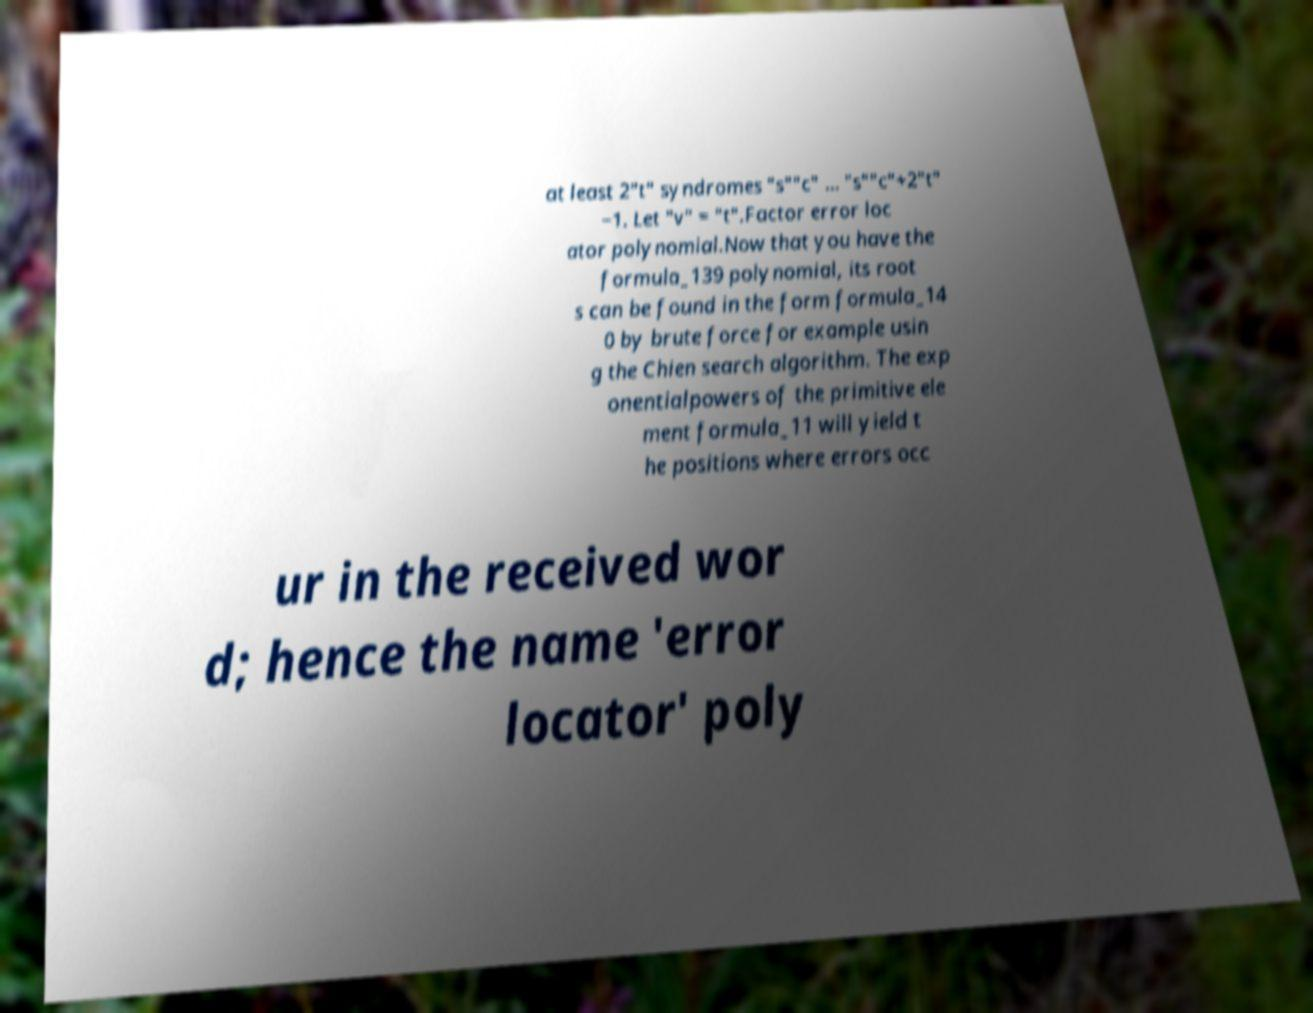I need the written content from this picture converted into text. Can you do that? at least 2"t" syndromes "s""c" … "s""c"+2"t" −1. Let "v" = "t".Factor error loc ator polynomial.Now that you have the formula_139 polynomial, its root s can be found in the form formula_14 0 by brute force for example usin g the Chien search algorithm. The exp onentialpowers of the primitive ele ment formula_11 will yield t he positions where errors occ ur in the received wor d; hence the name 'error locator' poly 